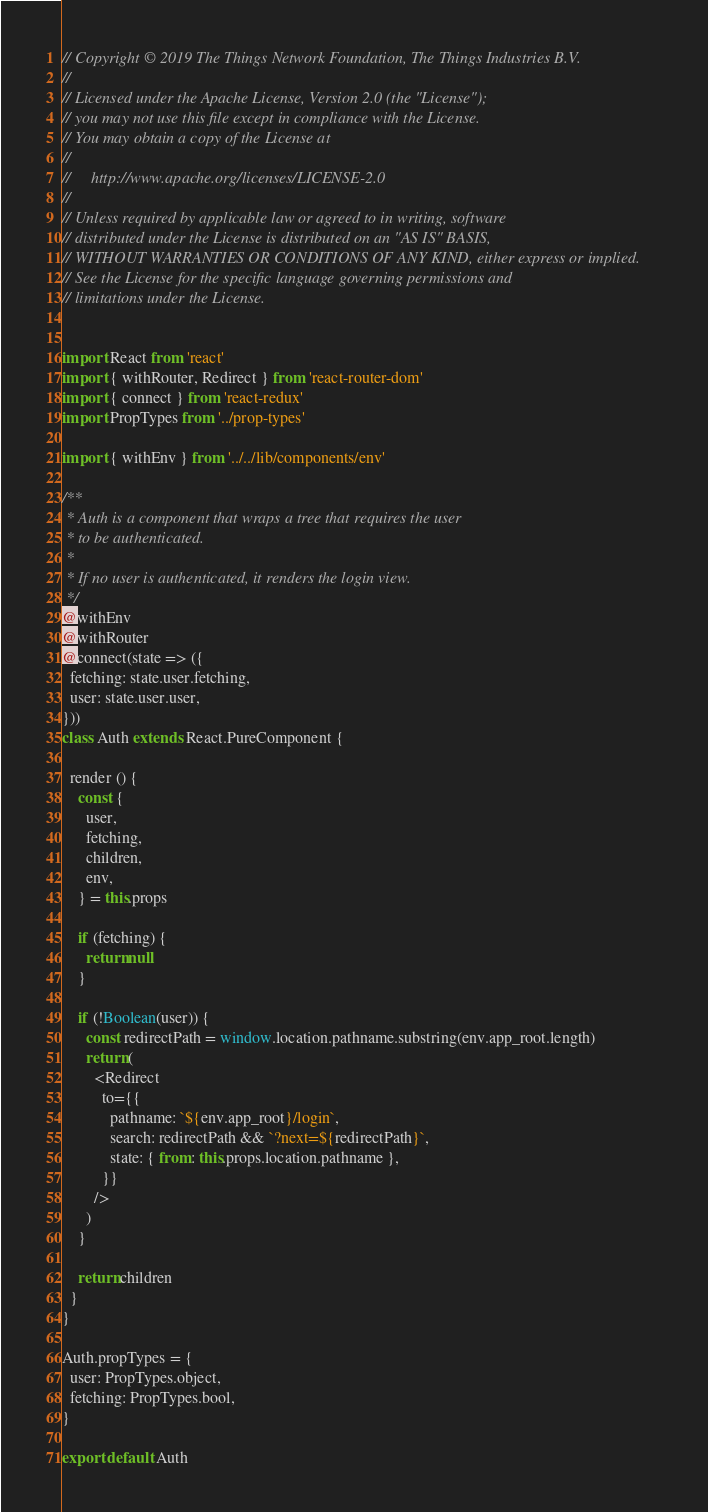Convert code to text. <code><loc_0><loc_0><loc_500><loc_500><_JavaScript_>// Copyright © 2019 The Things Network Foundation, The Things Industries B.V.
//
// Licensed under the Apache License, Version 2.0 (the "License");
// you may not use this file except in compliance with the License.
// You may obtain a copy of the License at
//
//     http://www.apache.org/licenses/LICENSE-2.0
//
// Unless required by applicable law or agreed to in writing, software
// distributed under the License is distributed on an "AS IS" BASIS,
// WITHOUT WARRANTIES OR CONDITIONS OF ANY KIND, either express or implied.
// See the License for the specific language governing permissions and
// limitations under the License.


import React from 'react'
import { withRouter, Redirect } from 'react-router-dom'
import { connect } from 'react-redux'
import PropTypes from '../prop-types'

import { withEnv } from '../../lib/components/env'

/**
 * Auth is a component that wraps a tree that requires the user
 * to be authenticated.
 *
 * If no user is authenticated, it renders the login view.
 */
@withEnv
@withRouter
@connect(state => ({
  fetching: state.user.fetching,
  user: state.user.user,
}))
class Auth extends React.PureComponent {

  render () {
    const {
      user,
      fetching,
      children,
      env,
    } = this.props

    if (fetching) {
      return null
    }

    if (!Boolean(user)) {
      const redirectPath = window.location.pathname.substring(env.app_root.length)
      return (
        <Redirect
          to={{
            pathname: `${env.app_root}/login`,
            search: redirectPath && `?next=${redirectPath}`,
            state: { from: this.props.location.pathname },
          }}
        />
      )
    }

    return children
  }
}

Auth.propTypes = {
  user: PropTypes.object,
  fetching: PropTypes.bool,
}

export default Auth
</code> 